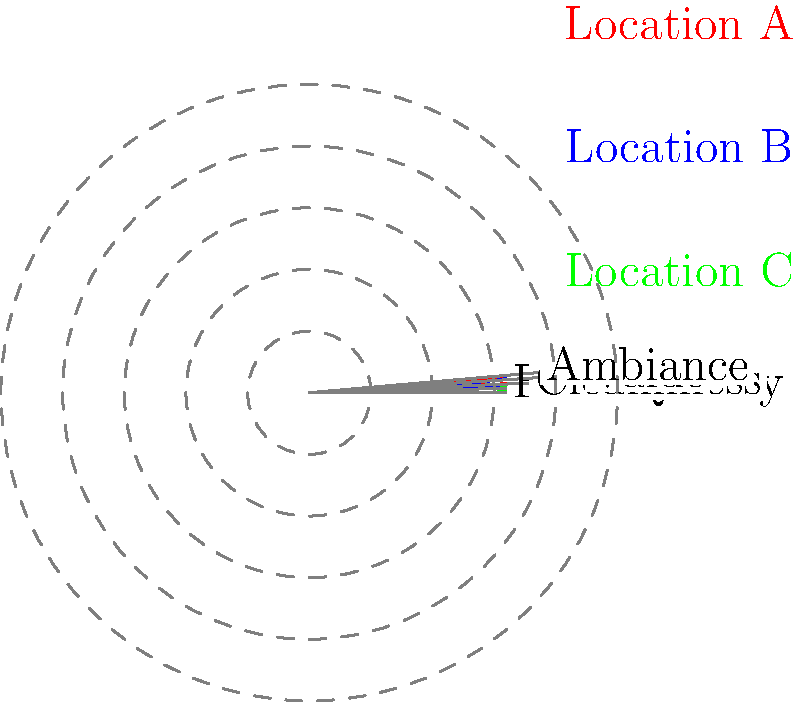Based on the radar chart comparing three franchise locations, which location demonstrates the best overall performance across all categories? To determine the best overall performance, we need to analyze each location's ratings across all five categories:

1. Location A (Red):
   Service: 5, Food Quality: 4, Cleanliness: 3, Value: 5, Ambiance: 2
   Total: 19

2. Location B (Blue):
   Service: 4, Food Quality: 5, Cleanliness: 2, Value: 3, Ambiance: 4
   Total: 18

3. Location C (Green):
   Service: 3, Food Quality: 3, Cleanliness: 4, Value: 4, Ambiance: 5
   Total: 19

Step 1: Compare total scores
Location A and C both have a total score of 19, while Location B has a total of 18.

Step 2: Analyze consistency
Location C shows the most consistent performance across all categories, with scores ranging from 3 to 5.
Location A has high scores in Service and Value but performs poorly in Ambiance.
Location B has more variation in its scores, ranging from 2 to 5.

Step 3: Consider balanced performance
Location C demonstrates a more balanced performance across all categories, which is generally preferable for overall franchise success.

Therefore, while Location A and C have the same total score, Location C's more consistent and balanced performance makes it the best overall performer.
Answer: Location C 